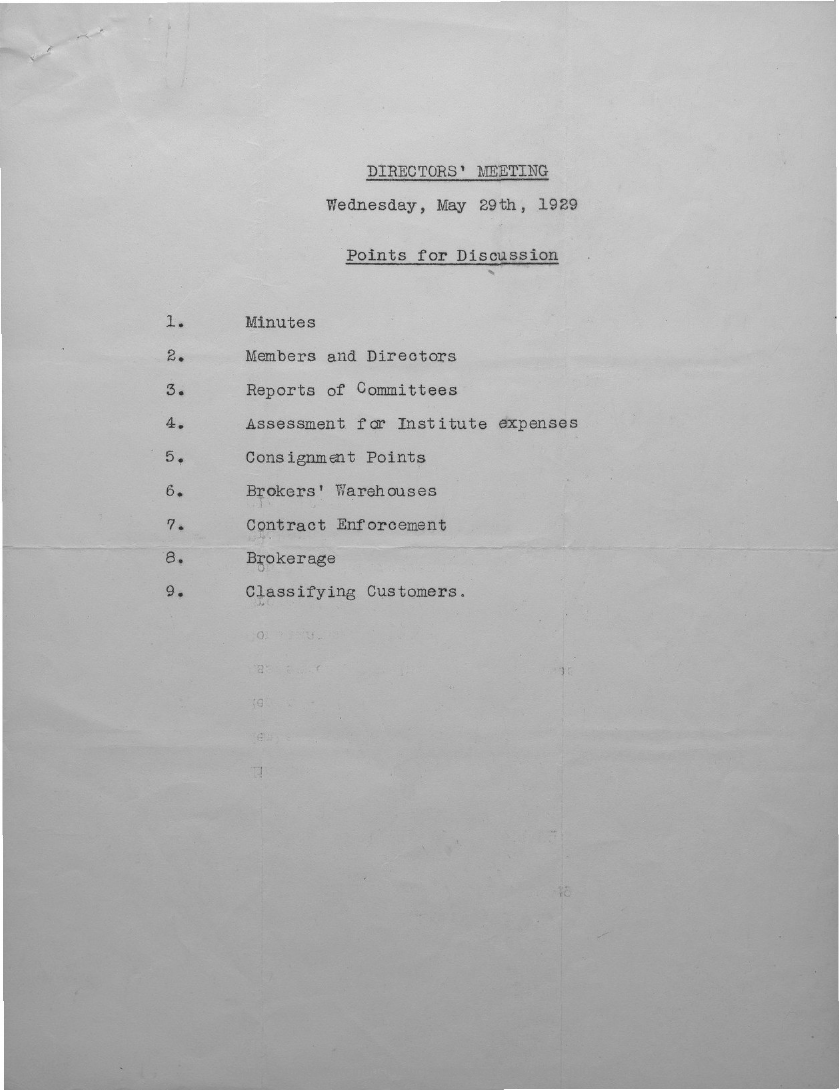When is the directors' meeting held?
Offer a terse response. May 29th, 1929. 